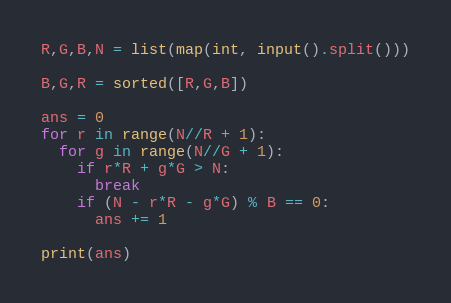Convert code to text. <code><loc_0><loc_0><loc_500><loc_500><_Python_>R,G,B,N = list(map(int, input().split()))

B,G,R = sorted([R,G,B])

ans = 0
for r in range(N//R + 1):
  for g in range(N//G + 1):
    if r*R + g*G > N:
      break
    if (N - r*R - g*G) % B == 0:
      ans += 1
      
print(ans)</code> 